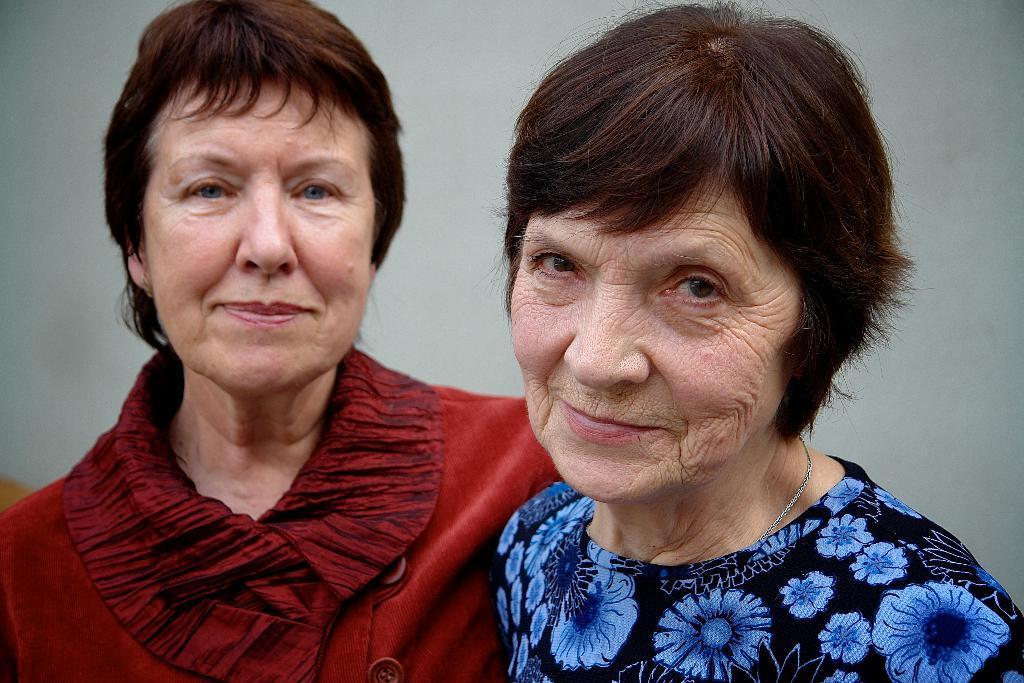Describe this image in one or two sentences. In this picture we can see two women smiling and in the background we can see wall. 